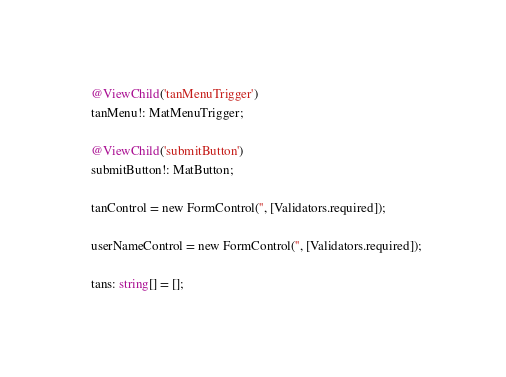Convert code to text. <code><loc_0><loc_0><loc_500><loc_500><_TypeScript_>  @ViewChild('tanMenuTrigger')
  tanMenu!: MatMenuTrigger;

  @ViewChild('submitButton')
  submitButton!: MatButton;

  tanControl = new FormControl('', [Validators.required]);

  userNameControl = new FormControl('', [Validators.required]);

  tans: string[] = [];
</code> 